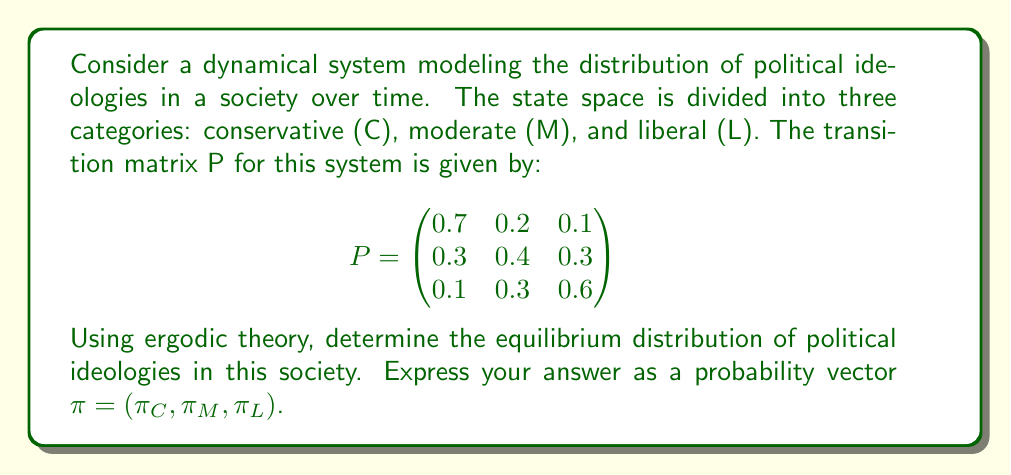Can you answer this question? To solve this problem, we'll use the principles of ergodic theory and Markov chains:

1. In an ergodic Markov chain, the equilibrium distribution $\pi$ satisfies the equation:

   $$\pi P = \pi$$

2. This means that $\pi$ is a left eigenvector of P with eigenvalue 1.

3. We also know that the components of $\pi$ must sum to 1:

   $$\pi_C + \pi_M + \pi_L = 1$$

4. Let's set up the system of equations:

   $$\begin{cases}
   0.7\pi_C + 0.3\pi_M + 0.1\pi_L = \pi_C \\
   0.2\pi_C + 0.4\pi_M + 0.3\pi_L = \pi_M \\
   0.1\pi_C + 0.3\pi_M + 0.6\pi_L = \pi_L \\
   \pi_C + \pi_M + \pi_L = 1
   \end{cases}$$

5. Simplify the first three equations:

   $$\begin{cases}
   -0.3\pi_C + 0.3\pi_M + 0.1\pi_L = 0 \\
   0.2\pi_C - 0.6\pi_M + 0.3\pi_L = 0 \\
   0.1\pi_C + 0.3\pi_M - 0.4\pi_L = 0 \\
   \pi_C + \pi_M + \pi_L = 1
   \end{cases}$$

6. Solve this system of equations. One method is to use Gaussian elimination or matrix methods. After solving, we get:

   $$\begin{cases}
   \pi_C = 0.375 \\
   \pi_M = 0.375 \\
   \pi_L = 0.25
   \end{cases}$$

7. Therefore, the equilibrium distribution is $\pi = (0.375, 0.375, 0.25)$.

This result suggests that in the long run, 37.5% of the population will be conservative, 37.5% will be moderate, and 25% will be liberal, regardless of the initial distribution.
Answer: $\pi = (0.375, 0.375, 0.25)$ 